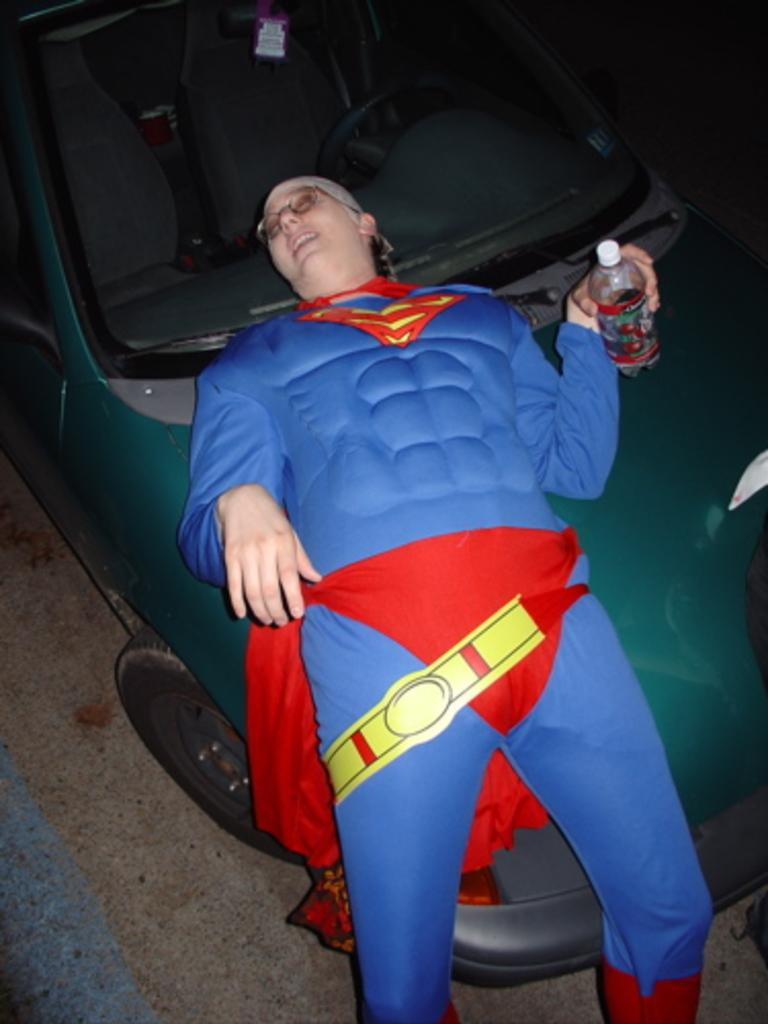Who is present in the image? There is a woman in the image. What is the woman holding in her hand? The woman is holding a bottle in her hand. How is the woman dressed? The woman is wearing a fancy dress. What can be seen in the background of the image? There is a car in the image. What type of cat can be seen cooking in the image? There is no cat or cooking activity present in the image. 